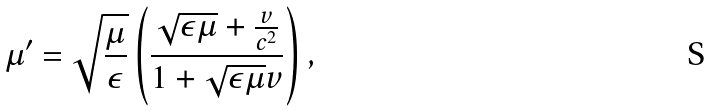Convert formula to latex. <formula><loc_0><loc_0><loc_500><loc_500>\mu ^ { \prime } = \sqrt { \frac { \mu } { \epsilon } } \left ( \frac { \sqrt { \epsilon \mu } + \frac { v } { c ^ { 2 } } } { 1 + \sqrt { \epsilon \mu } v } \right ) ,</formula> 